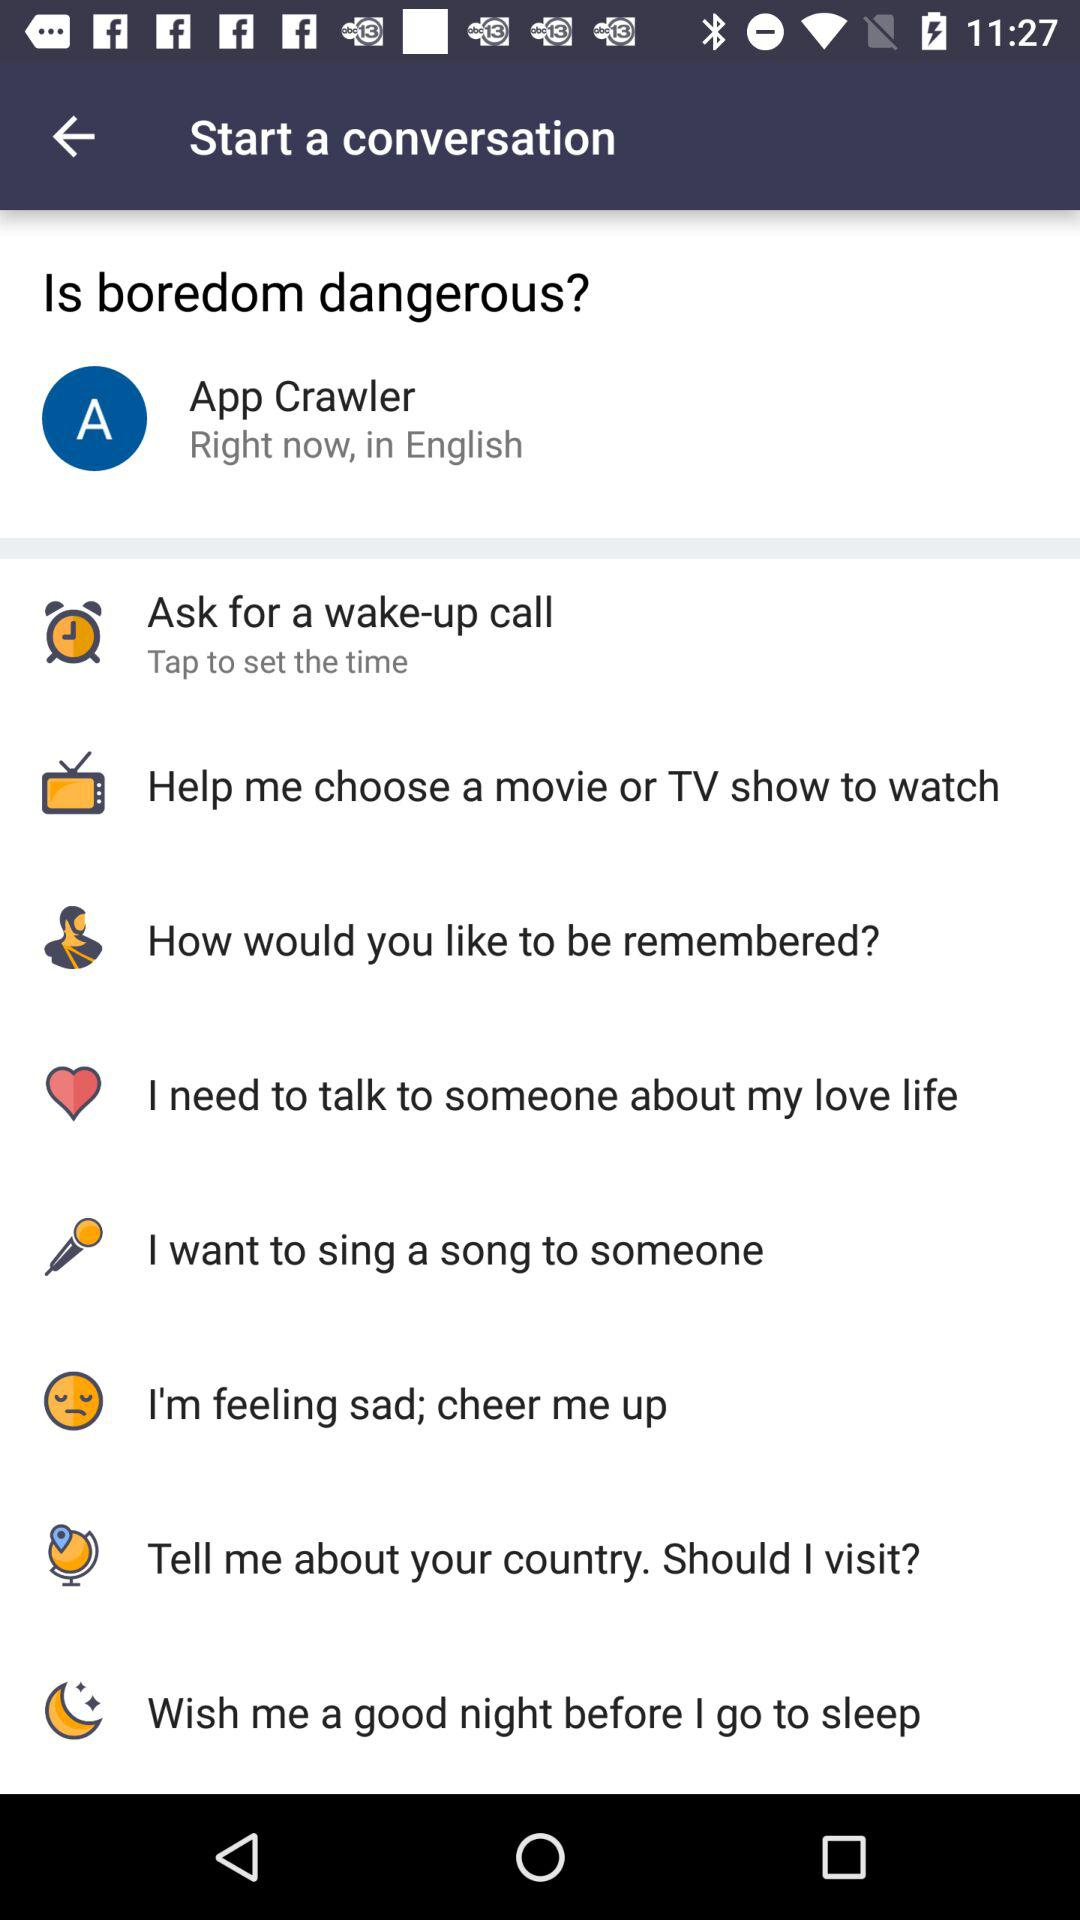What is the mentioned conversation language? The mentioned conversation language is English. 